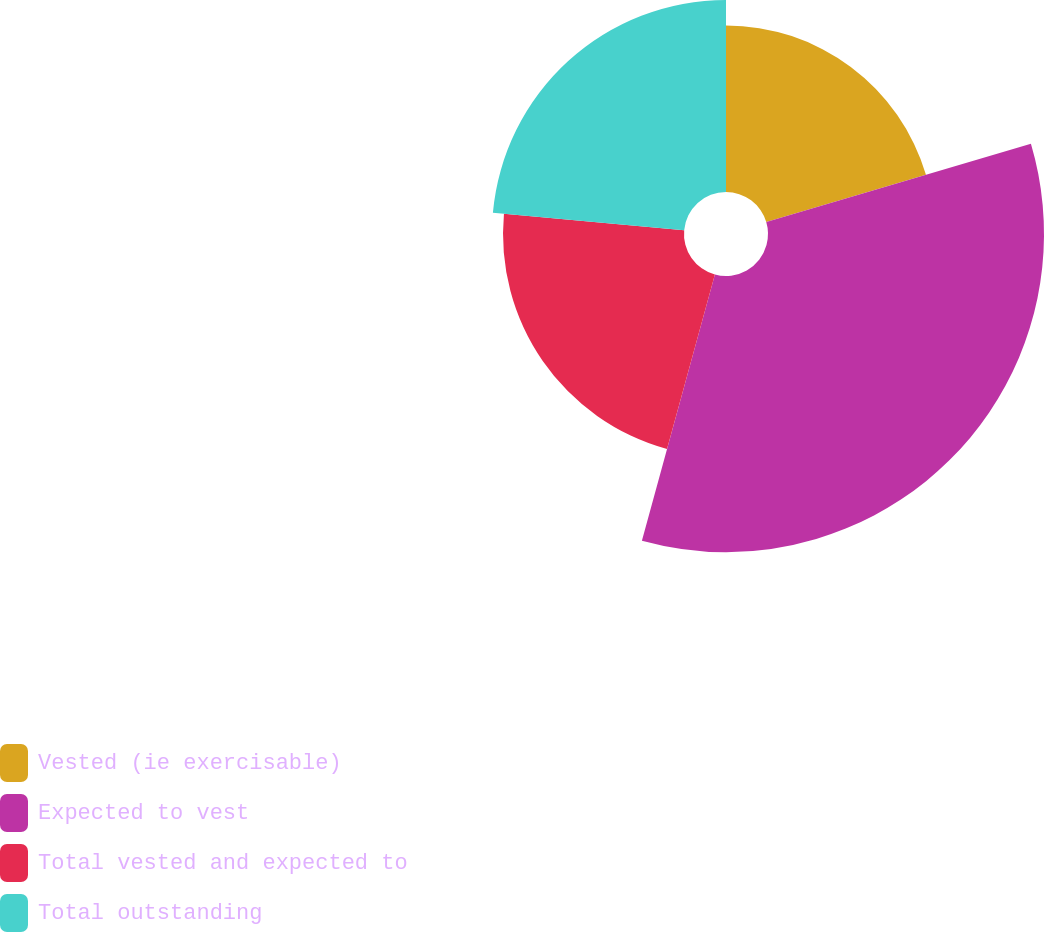<chart> <loc_0><loc_0><loc_500><loc_500><pie_chart><fcel>Vested (ie exercisable)<fcel>Expected to vest<fcel>Total vested and expected to<fcel>Total outstanding<nl><fcel>20.42%<fcel>33.84%<fcel>22.19%<fcel>23.55%<nl></chart> 